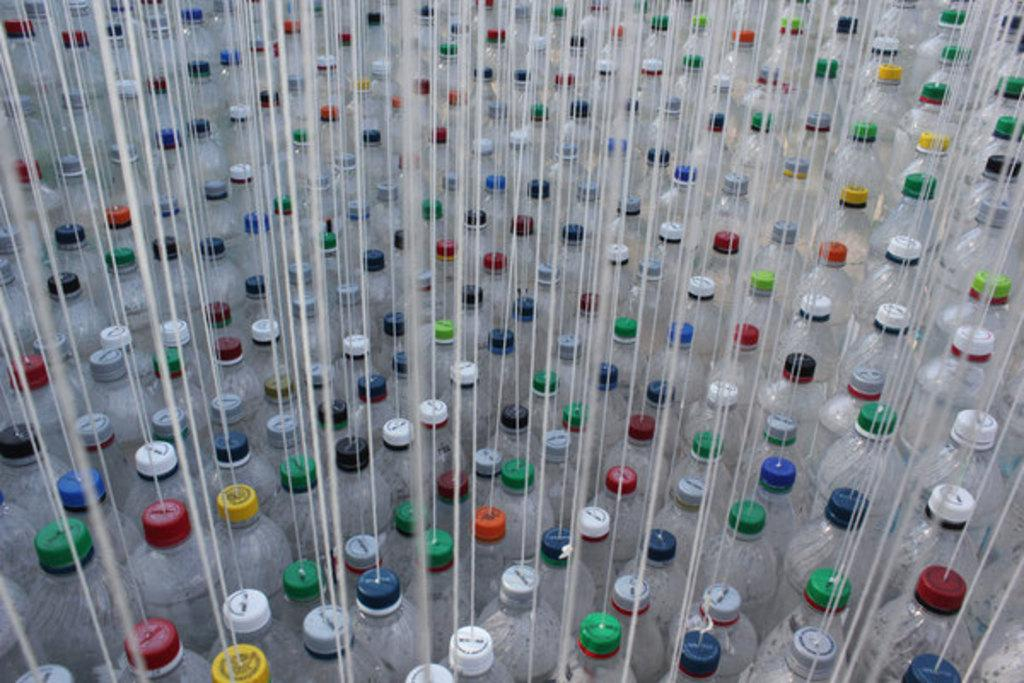What objects can be seen in the image? There are bottles in the image. What additional feature can be observed on the bottles? There are threads on the bottles. Can you tell me how many hens are sitting on the bottles in the image? There are no hens present in the image; it only features bottles with threads on them. What type of force is being applied to the bottles in the image? The image does not provide information about any forces being applied to the bottles, so it cannot be determined from the picture. 